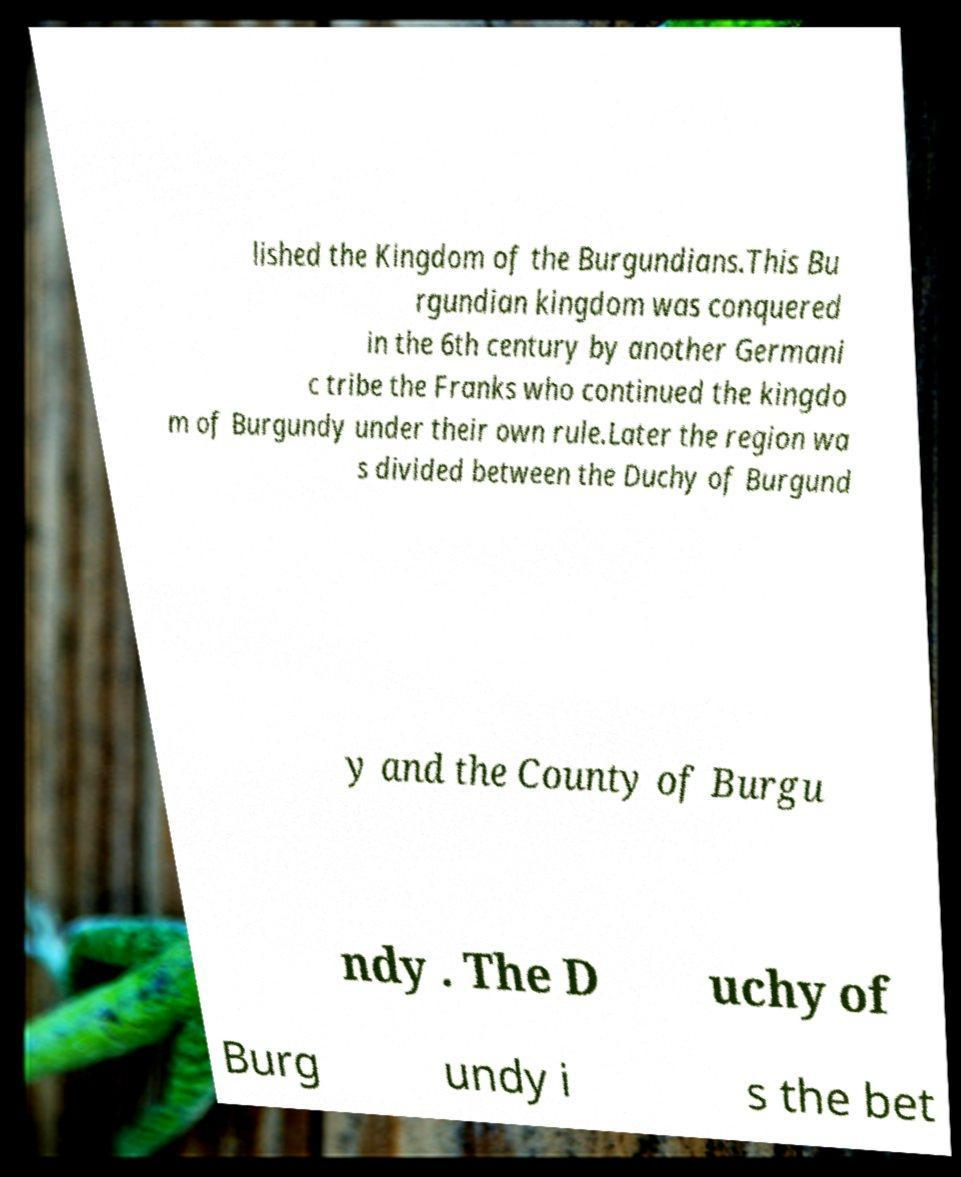Could you extract and type out the text from this image? lished the Kingdom of the Burgundians.This Bu rgundian kingdom was conquered in the 6th century by another Germani c tribe the Franks who continued the kingdo m of Burgundy under their own rule.Later the region wa s divided between the Duchy of Burgund y and the County of Burgu ndy . The D uchy of Burg undy i s the bet 